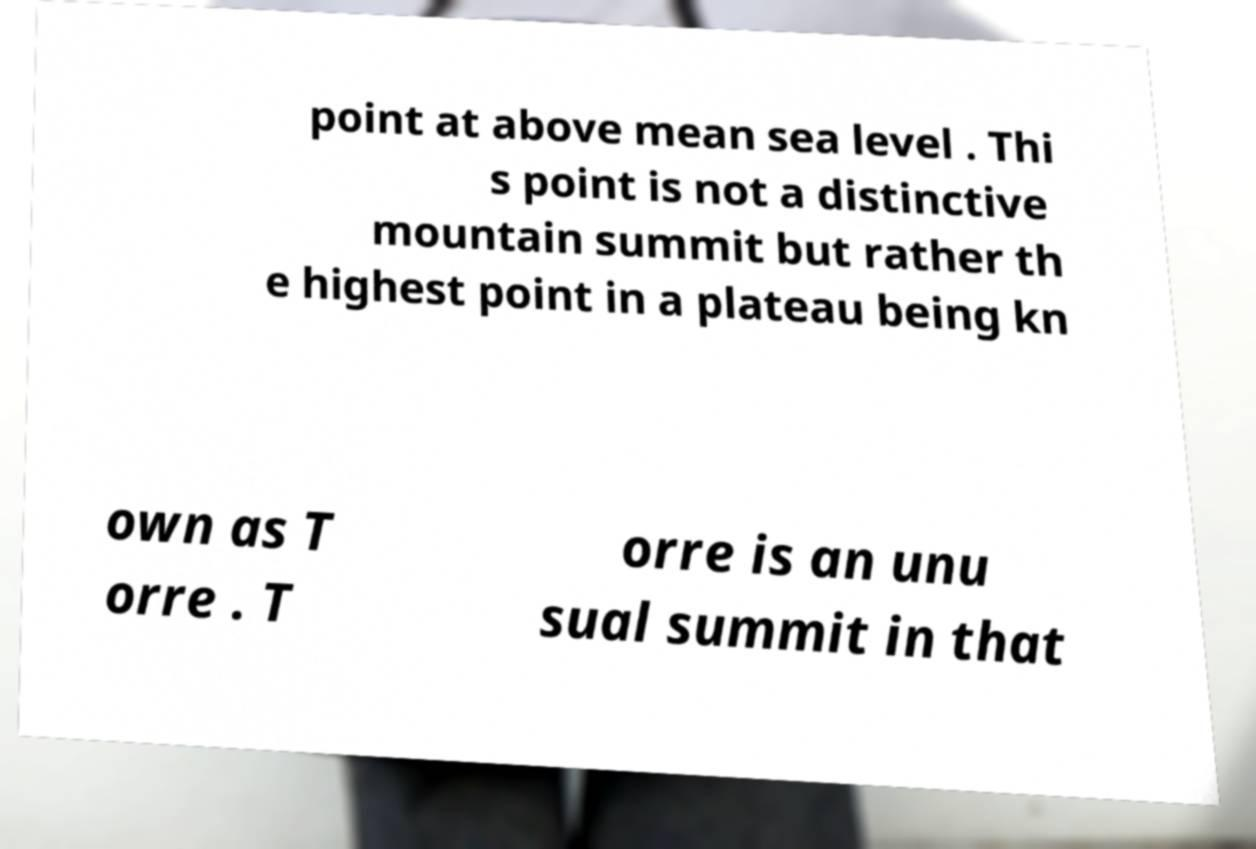I need the written content from this picture converted into text. Can you do that? point at above mean sea level . Thi s point is not a distinctive mountain summit but rather th e highest point in a plateau being kn own as T orre . T orre is an unu sual summit in that 